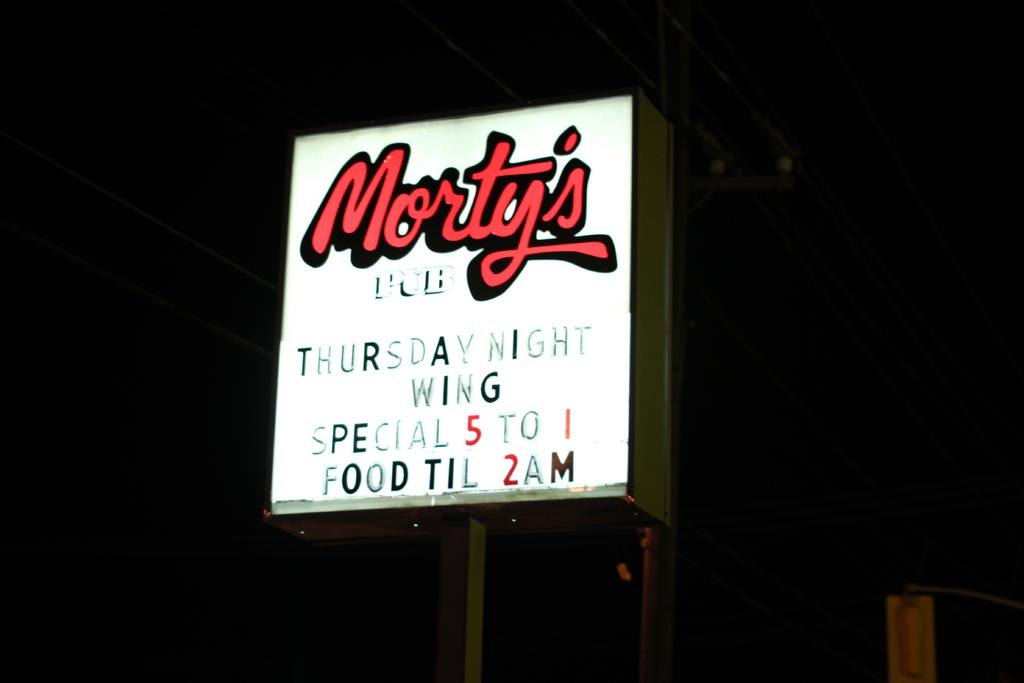<image>
Summarize the visual content of the image. A lit sign for Morty's Pub, Thursday's special is wings and they are open until 2am for food. 